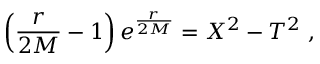<formula> <loc_0><loc_0><loc_500><loc_500>\left ( { \frac { r } { 2 M } } - 1 \right ) e ^ { { \frac { r } { 2 M } } } = X ^ { 2 } - T ^ { 2 } \, ,</formula> 